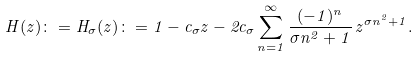<formula> <loc_0><loc_0><loc_500><loc_500>H ( z ) \colon = H _ { \sigma } ( z ) \colon = 1 - c _ { \sigma } z - 2 c _ { \sigma } \sum _ { n = 1 } ^ { \infty } \frac { ( - 1 ) ^ { n } } { \sigma n ^ { 2 } + 1 } \, z ^ { \sigma n ^ { 2 } + 1 } .</formula> 